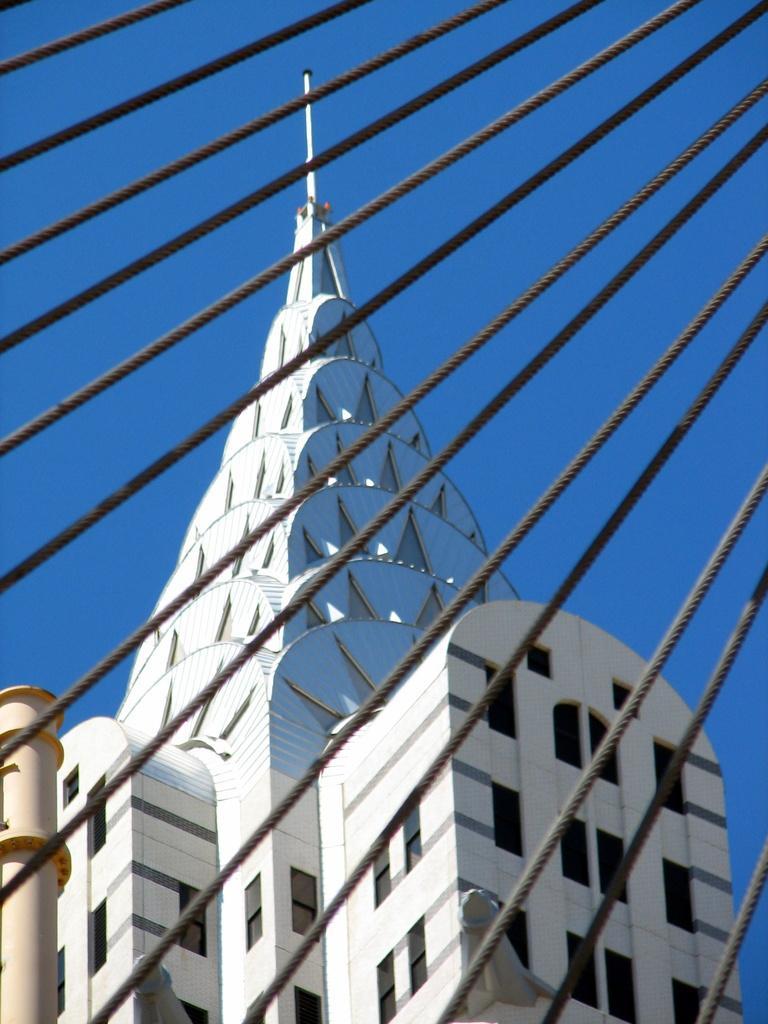Please provide a concise description of this image. In this image I can see a tower or a multi story building through a couple of poles arranged parallel. I can see the sky at the top of the image. 